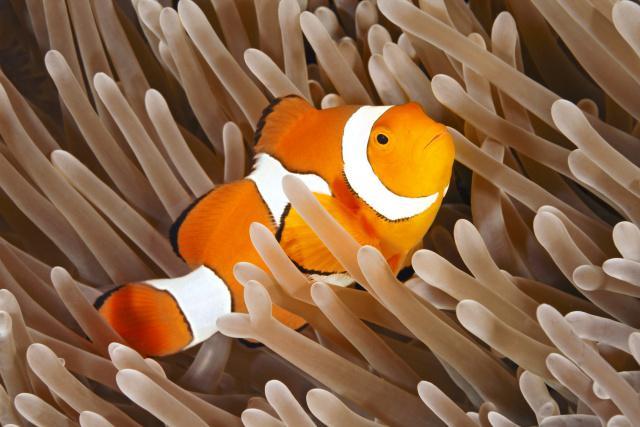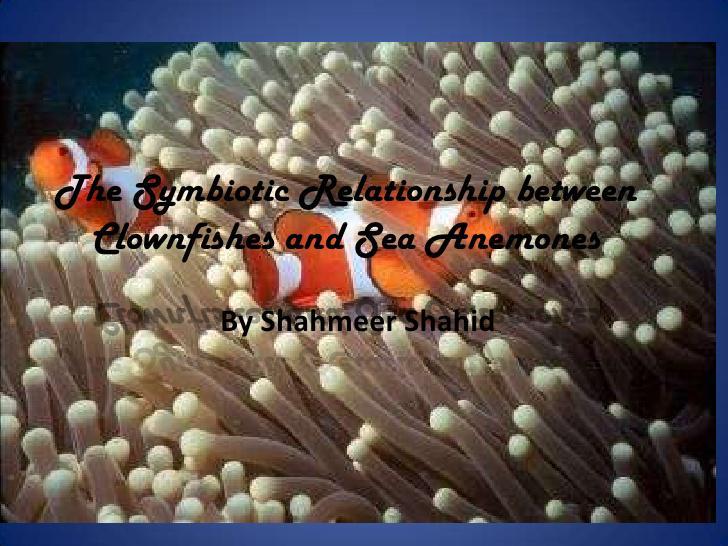The first image is the image on the left, the second image is the image on the right. For the images displayed, is the sentence "In at least one image there is a single clownfish swimming right forward through arms of corral." factually correct? Answer yes or no. Yes. The first image is the image on the left, the second image is the image on the right. Considering the images on both sides, is "One image shows exactly one clownfish, which is angled facing rightward above pale anemone tendrils, and the other image includes two clownfish with three stripes each visible in the foreground swimming by pale anemone tendrils." valid? Answer yes or no. Yes. 